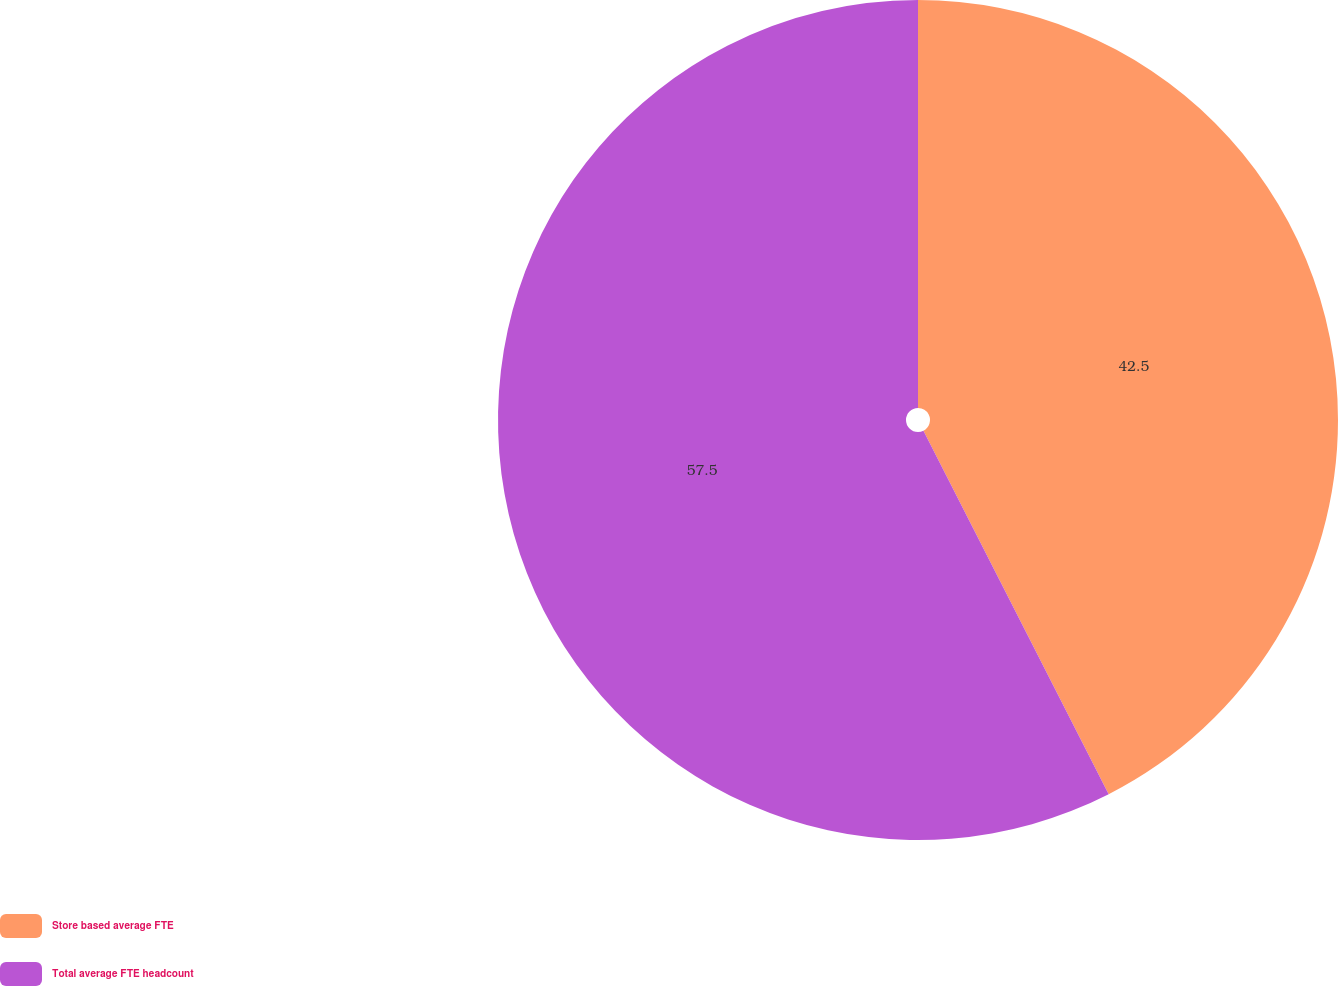<chart> <loc_0><loc_0><loc_500><loc_500><pie_chart><fcel>Store based average FTE<fcel>Total average FTE headcount<nl><fcel>42.5%<fcel>57.5%<nl></chart> 